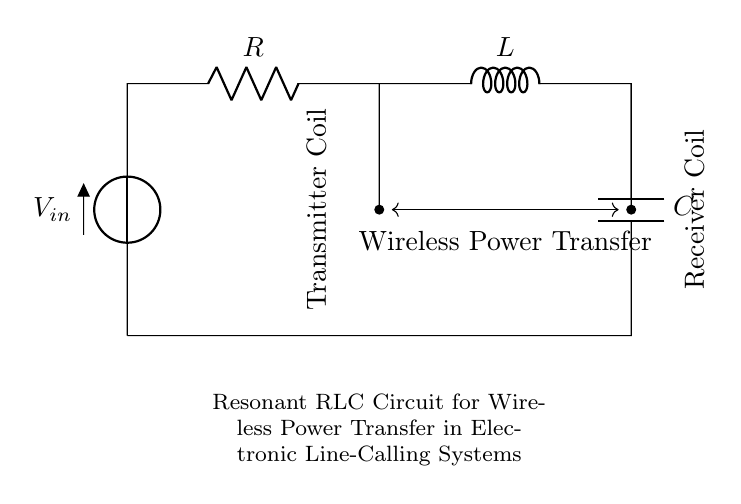What are the components in this circuit? The components are a resistor, an inductor, and a capacitor, which are clearly labeled in the circuit diagram.
Answer: Resistor, Inductor, Capacitor What is the function of the transmitter coil? The transmitter coil acts as an inductor in the circuit, facilitating energy transfer through electromagnetic induction.
Answer: Inductor What is the purpose of the resistor in this circuit? The resistor limits current flow and dissipates energy as heat, ensuring the circuit operates within safe limits.
Answer: Limits current What type of circuit is this? This circuit is a resonant RLC circuit, indicated by the specific arrangement of the resistor, inductor, and capacitor designed for resonance.
Answer: Resonant RLC circuit What is the main objective of this circuit? The main objective is wireless power transfer, which is indicated by the labels and connections in the circuit diagram.
Answer: Wireless power transfer How does the capacitor influence the circuit's operation? The capacitor stores and releases electrical energy, which, along with the inductor, determines the resonant frequency of the circuit.
Answer: Stores energy What does the arrow between the coils signify? The arrow signifies that there is wireless power transfer occurring between the transmitter and receiver coils in the circuit.
Answer: Wireless power transfer 